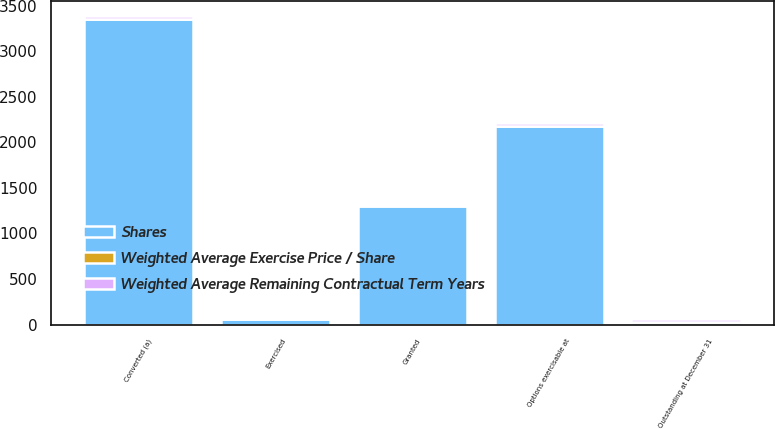Convert chart to OTSL. <chart><loc_0><loc_0><loc_500><loc_500><stacked_bar_chart><ecel><fcel>Converted (a)<fcel>Granted<fcel>Exercised<fcel>Outstanding at December 31<fcel>Options exercisable at<nl><fcel>Shares<fcel>3354<fcel>1298<fcel>62<fcel>25.1<fcel>2182<nl><fcel>Weighted Average Remaining Contractual Term Years<fcel>26.15<fcel>24.58<fcel>16.85<fcel>25.83<fcel>25.62<nl><fcel>Weighted Average Exercise Price / Share<fcel>3.5<fcel>9.9<fcel>0.1<fcel>5.4<fcel>1.8<nl></chart> 